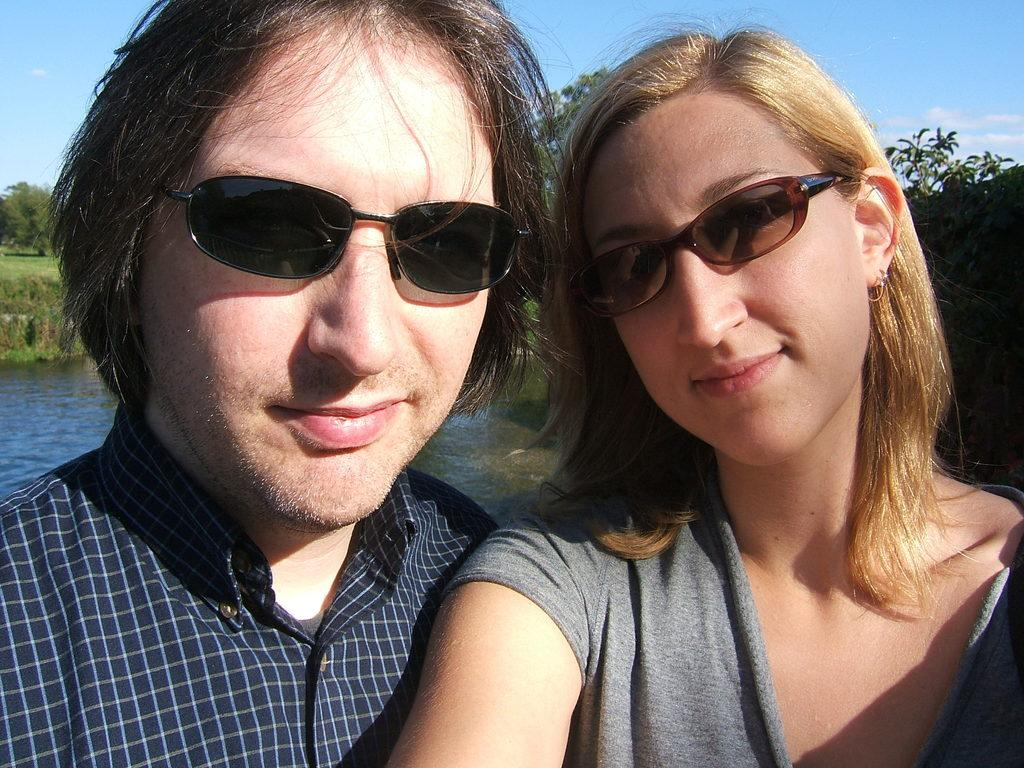How many people are in the image? There are two persons in the image. What type of natural environment is visible in the image? There are trees, grassy land, and a lake visible in the image. What type of record is being played by the minister in the image? There is no minister or record present in the image. What type of cart is being used to transport the lake in the image? There is no cart or transportation of the lake in the image; it is a natural body of water. 